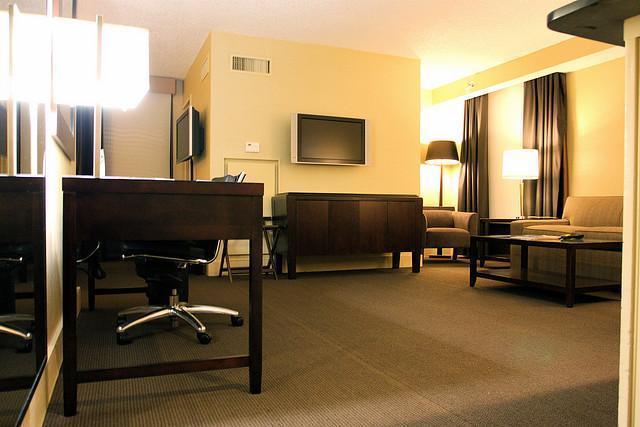How many chairs are in the picture?
Give a very brief answer. 2. How many couches can be seen?
Give a very brief answer. 2. 